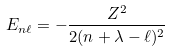Convert formula to latex. <formula><loc_0><loc_0><loc_500><loc_500>E _ { n \ell } = - { \frac { Z ^ { 2 } } { 2 ( n + \lambda - \ell ) ^ { 2 } } }</formula> 